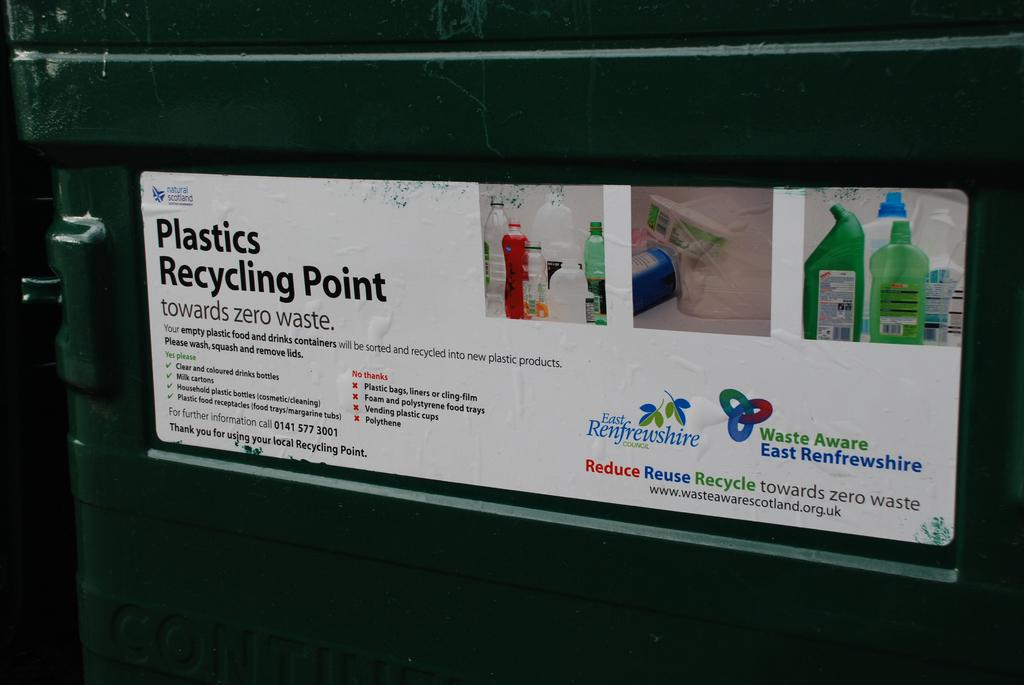<image>
Render a clear and concise summary of the photo. a poster that is titaled 'plastics recycling point towards zero waste' 